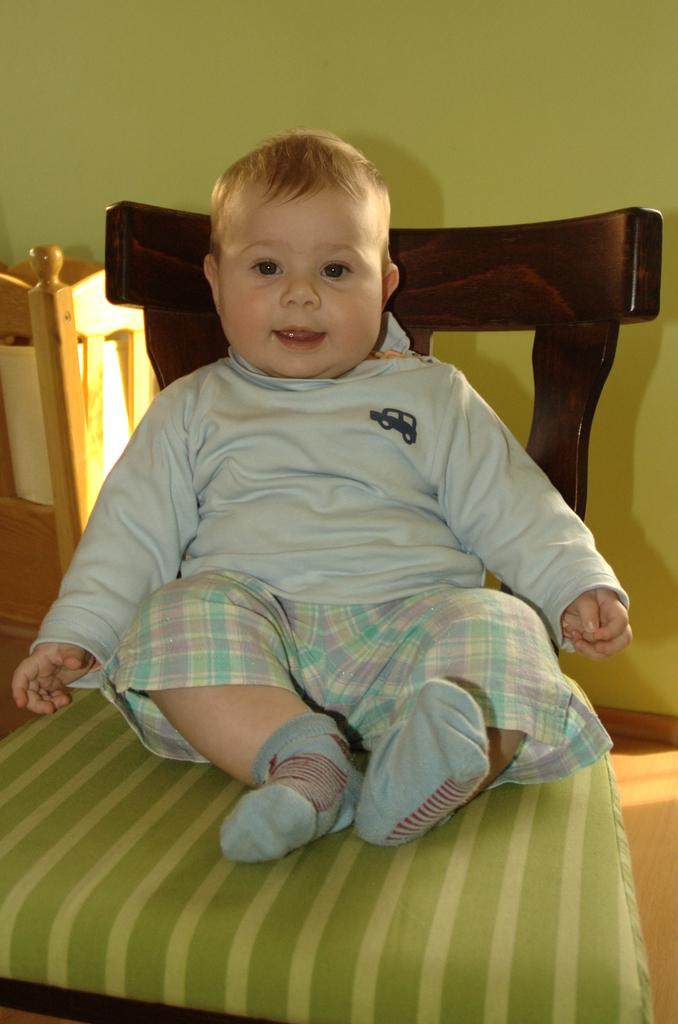What is the kid doing in the image? The kid is sitting on a chair in the image. What can be seen in the background of the image? There is a wooden object and a wall in the background of the image. What is visible beneath the kid's feet? The floor is visible in the image. What type of dinner is the kid eating in the image? There is no dinner present in the image; the kid is simply sitting on a chair. Can you describe the man standing next to the kid in the image? There is no man present in the image; only the kid sitting on a chair and the background elements are visible. 